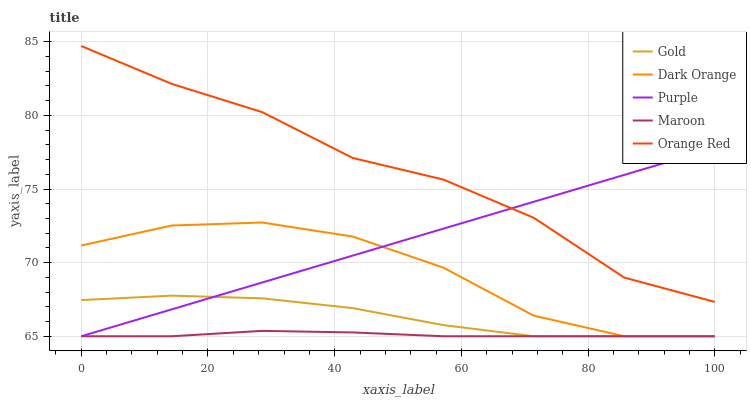Does Dark Orange have the minimum area under the curve?
Answer yes or no. No. Does Dark Orange have the maximum area under the curve?
Answer yes or no. No. Is Dark Orange the smoothest?
Answer yes or no. No. Is Dark Orange the roughest?
Answer yes or no. No. Does Orange Red have the lowest value?
Answer yes or no. No. Does Dark Orange have the highest value?
Answer yes or no. No. Is Gold less than Orange Red?
Answer yes or no. Yes. Is Orange Red greater than Maroon?
Answer yes or no. Yes. Does Gold intersect Orange Red?
Answer yes or no. No. 